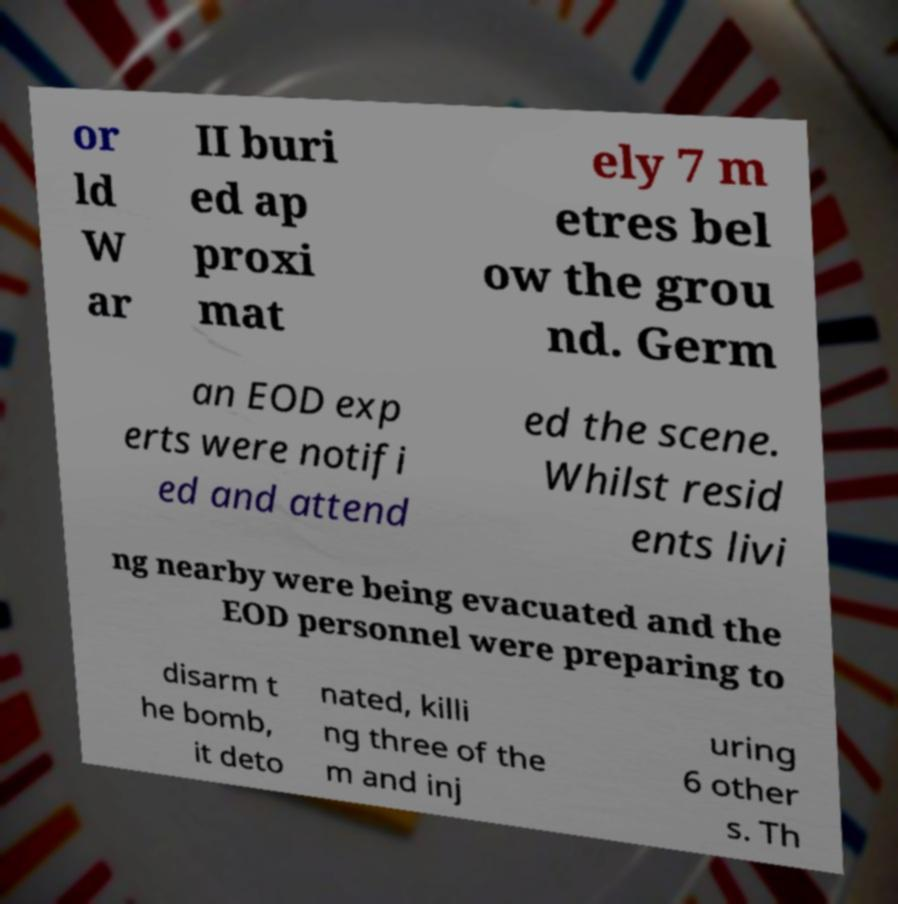Could you assist in decoding the text presented in this image and type it out clearly? or ld W ar II buri ed ap proxi mat ely 7 m etres bel ow the grou nd. Germ an EOD exp erts were notifi ed and attend ed the scene. Whilst resid ents livi ng nearby were being evacuated and the EOD personnel were preparing to disarm t he bomb, it deto nated, killi ng three of the m and inj uring 6 other s. Th 